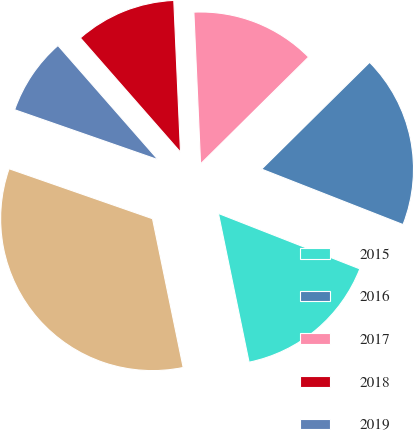Convert chart. <chart><loc_0><loc_0><loc_500><loc_500><pie_chart><fcel>2015<fcel>2016<fcel>2017<fcel>2018<fcel>2019<fcel>Next five fiscal years to<nl><fcel>15.82%<fcel>18.36%<fcel>13.29%<fcel>10.75%<fcel>8.21%<fcel>33.57%<nl></chart> 